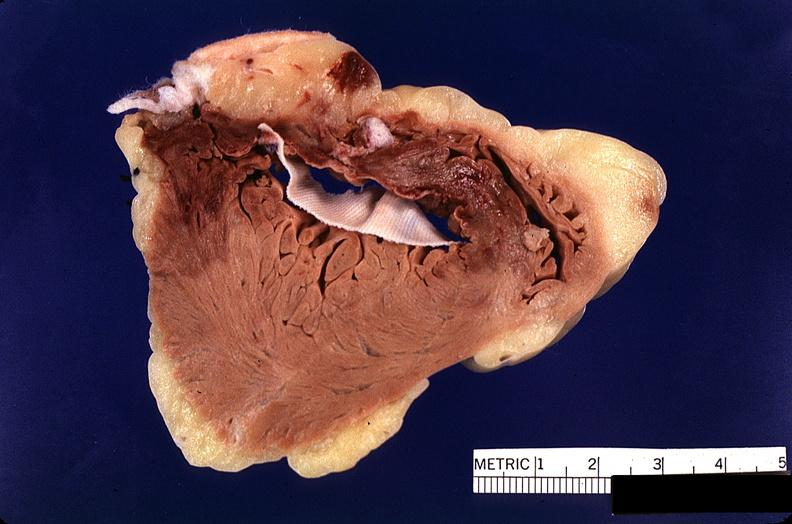what is present?
Answer the question using a single word or phrase. Cardiovascular 